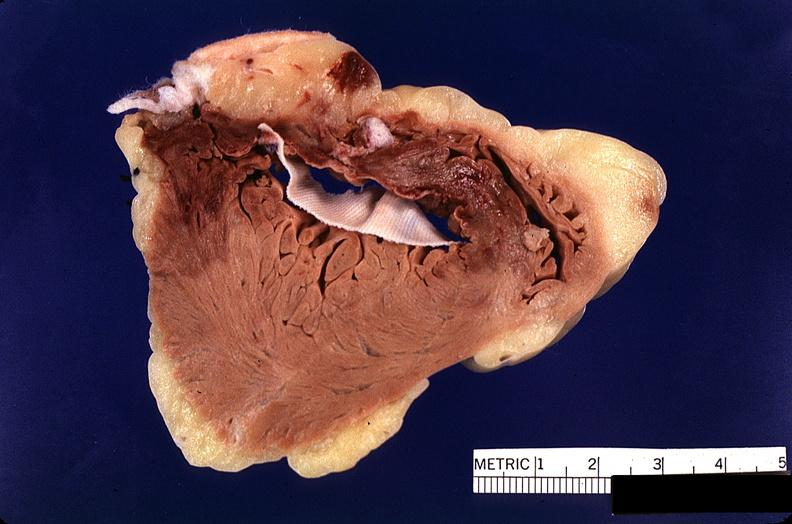what is present?
Answer the question using a single word or phrase. Cardiovascular 